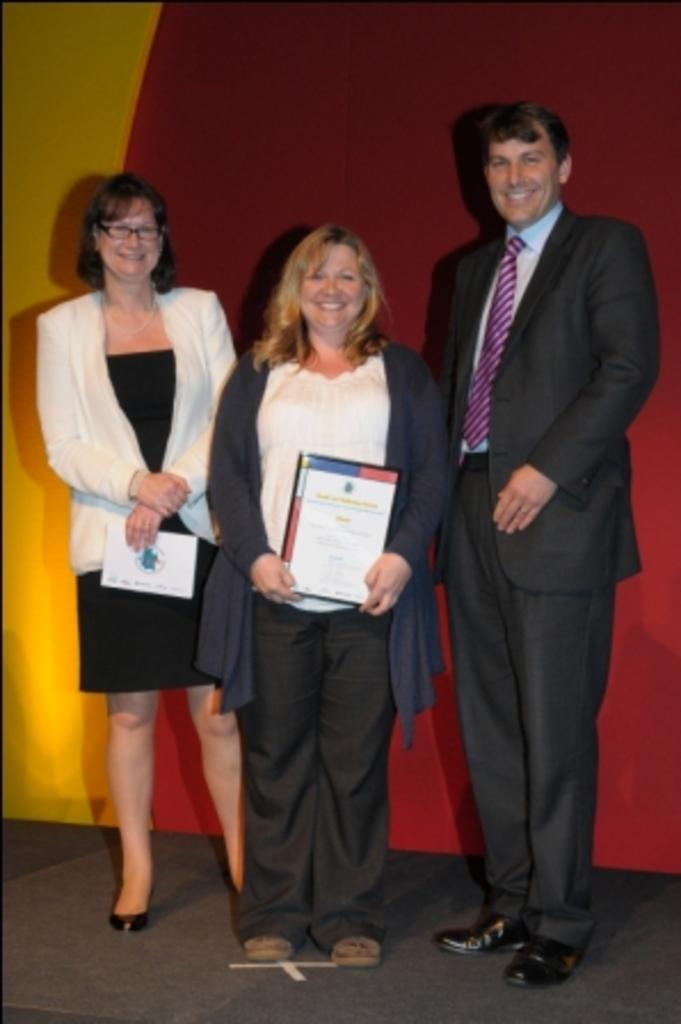Where was the image taken? The image was taken inside a room. How many people are in the image? There are two women and one man in the image. What is the position of the people in the image? The people are standing on the floor. What colors can be seen in the background of the image? There is a red color and a yellow color in the background of the image. What type of verse is being recited by the man in the image? There is no indication in the image that anyone is reciting a verse, so it cannot be determined from the picture. 